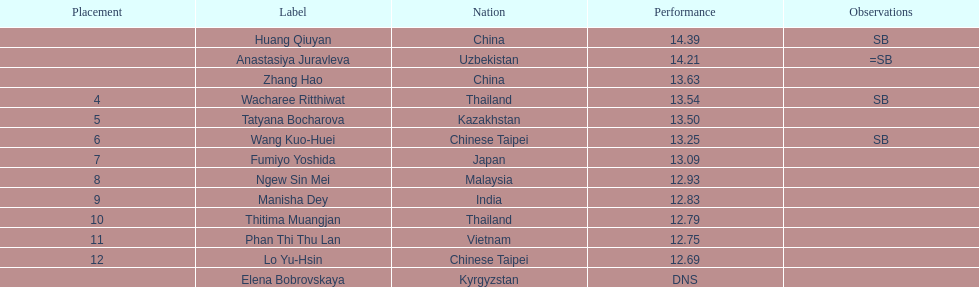What is the difference between huang qiuyan's result and fumiyo yoshida's result? 1.3. 